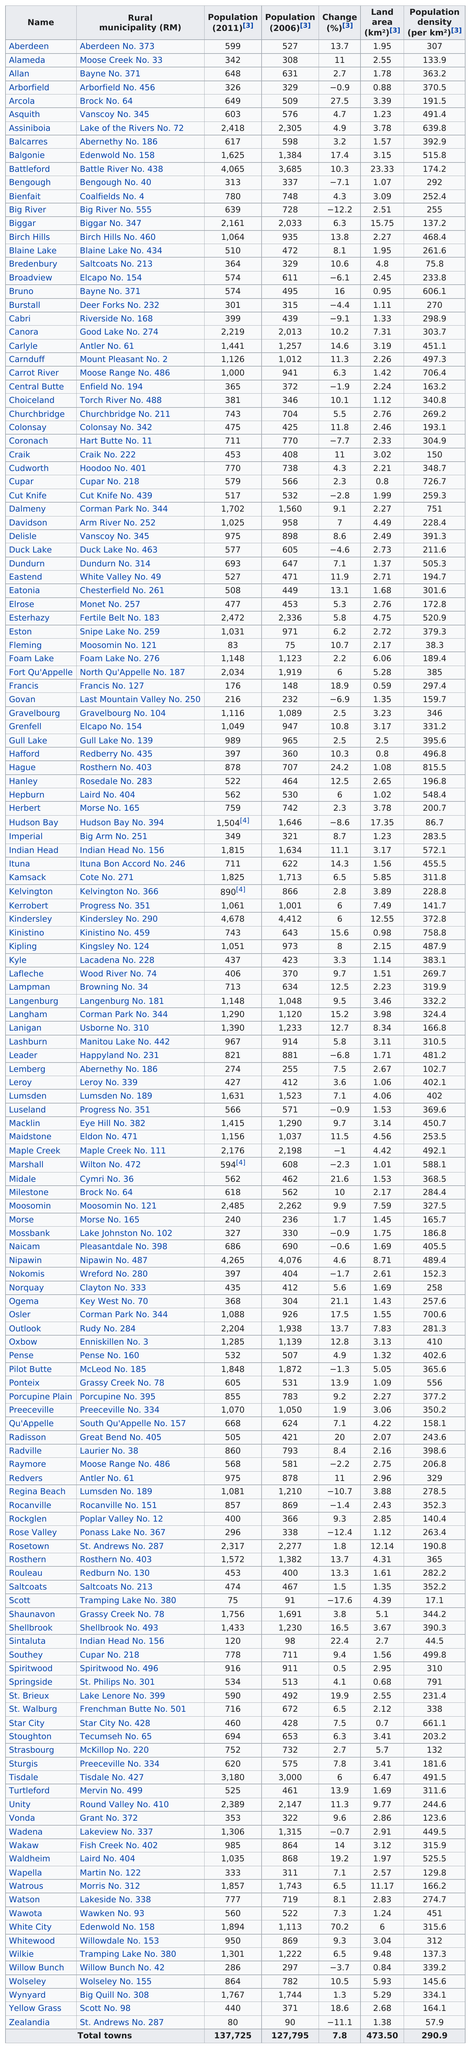Mention a couple of crucial points in this snapshot. Scott's city has the least amount of population. Allan and Birch Hills had different changes in population. Birch Hills experienced a larger population change compared to Allan. In 2011, the town of Broadview had the same population as Bruno. The town that comes after Porcupine Plain in alphabetical order is Preeceville. Kindersley had the largest population among the towns in 2011, according to the most recent census data. 